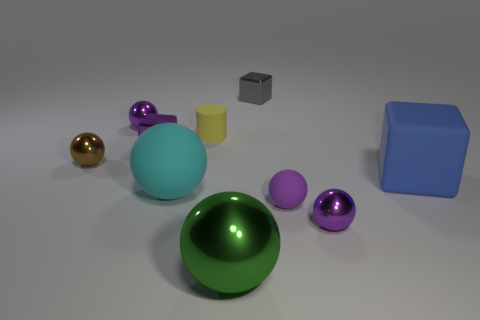Subtract all brown cubes. How many purple balls are left? 3 Subtract all brown spheres. How many spheres are left? 5 Subtract all big green balls. How many balls are left? 5 Subtract all brown cylinders. Subtract all purple blocks. How many cylinders are left? 1 Subtract all cylinders. How many objects are left? 9 Subtract all rubber cubes. Subtract all purple matte things. How many objects are left? 8 Add 2 small spheres. How many small spheres are left? 6 Add 1 small yellow objects. How many small yellow objects exist? 2 Subtract 1 gray blocks. How many objects are left? 9 